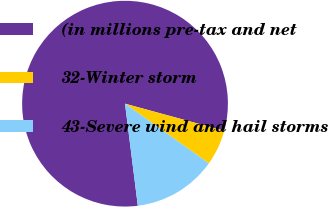Convert chart. <chart><loc_0><loc_0><loc_500><loc_500><pie_chart><fcel>(in millions pre-tax and net<fcel>32-Winter storm<fcel>43-Severe wind and hail storms<nl><fcel>81.23%<fcel>5.6%<fcel>13.17%<nl></chart> 